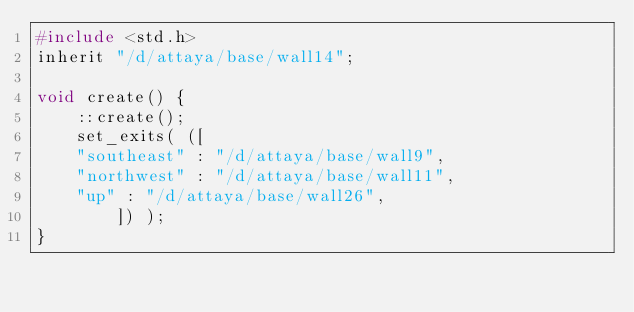Convert code to text. <code><loc_0><loc_0><loc_500><loc_500><_C_>#include <std.h>
inherit "/d/attaya/base/wall14";

void create() {
    ::create();
    set_exits( ([
    "southeast" : "/d/attaya/base/wall9",
    "northwest" : "/d/attaya/base/wall11",
    "up" : "/d/attaya/base/wall26",
        ]) );
}
</code> 